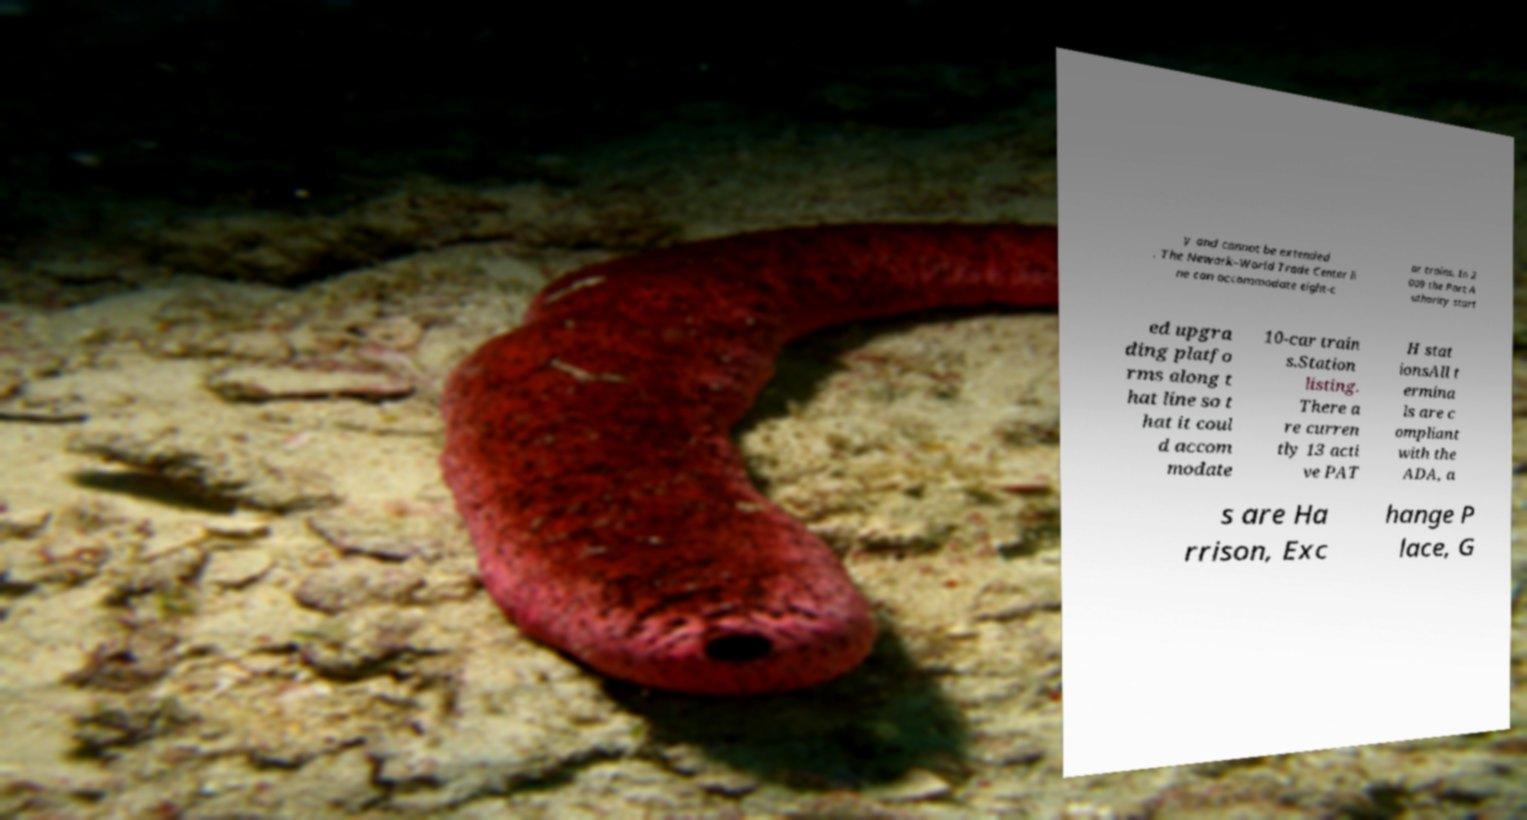Could you extract and type out the text from this image? y and cannot be extended . The Newark–World Trade Center li ne can accommodate eight-c ar trains. In 2 009 the Port A uthority start ed upgra ding platfo rms along t hat line so t hat it coul d accom modate 10-car train s.Station listing. There a re curren tly 13 acti ve PAT H stat ionsAll t ermina ls are c ompliant with the ADA, a s are Ha rrison, Exc hange P lace, G 